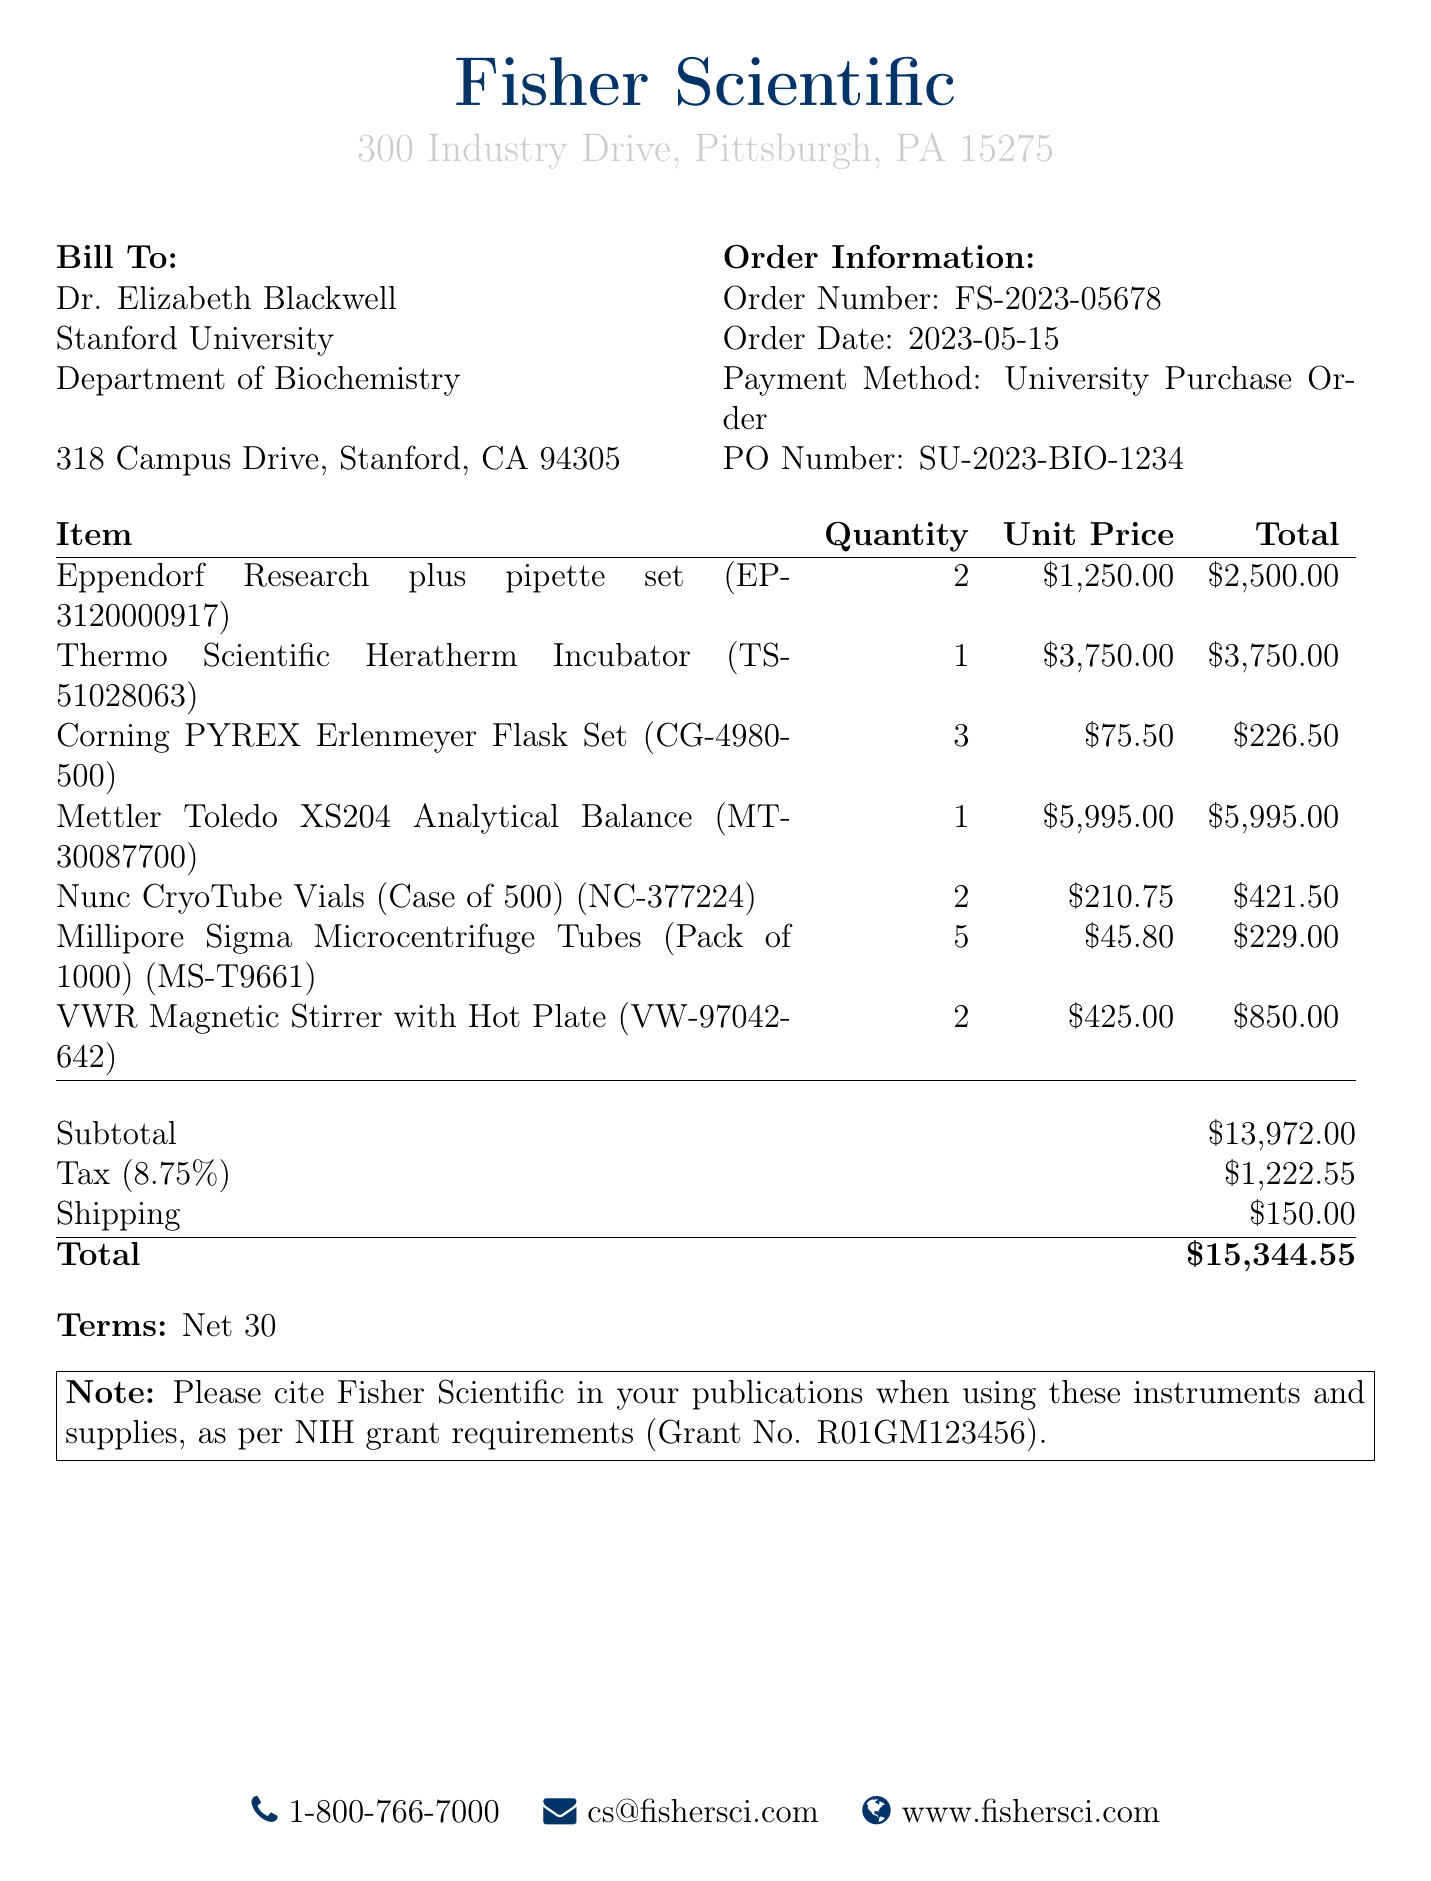What is the name of the supplier? The supplier's name is provided at the top of the receipt.
Answer: Fisher Scientific What is the order date? The receipt specifies the date when the order was made.
Answer: 2023-05-15 What is the total amount? The total amount is calculated based on the subtotal, tax, and shipping fees.
Answer: $15,344.55 How many Eppendorf pipette sets were ordered? The quantity of Eppendorf pipette sets is listed under the items section.
Answer: 2 What is the payment method used? The payment method is specified in the order information section of the document.
Answer: University Purchase Order What is the subtotal before tax? The subtotal is detailed in the summary of costs at the bottom of the document.
Answer: $13,972.00 What is the tax rate applied to the order? The tax rate is specified as a percentage in the breakdown of costs.
Answer: 8.75% How many different types of items were purchased? The total number of distinct items can be counted in the itemized list.
Answer: 7 What is the note regarding citation in publications? The receipt includes a note pertaining to the citation of the supplier in publications.
Answer: Please cite Fisher Scientific in your publications when using these instruments and supplies, as per NIH grant requirements (Grant No. R01GM123456) 